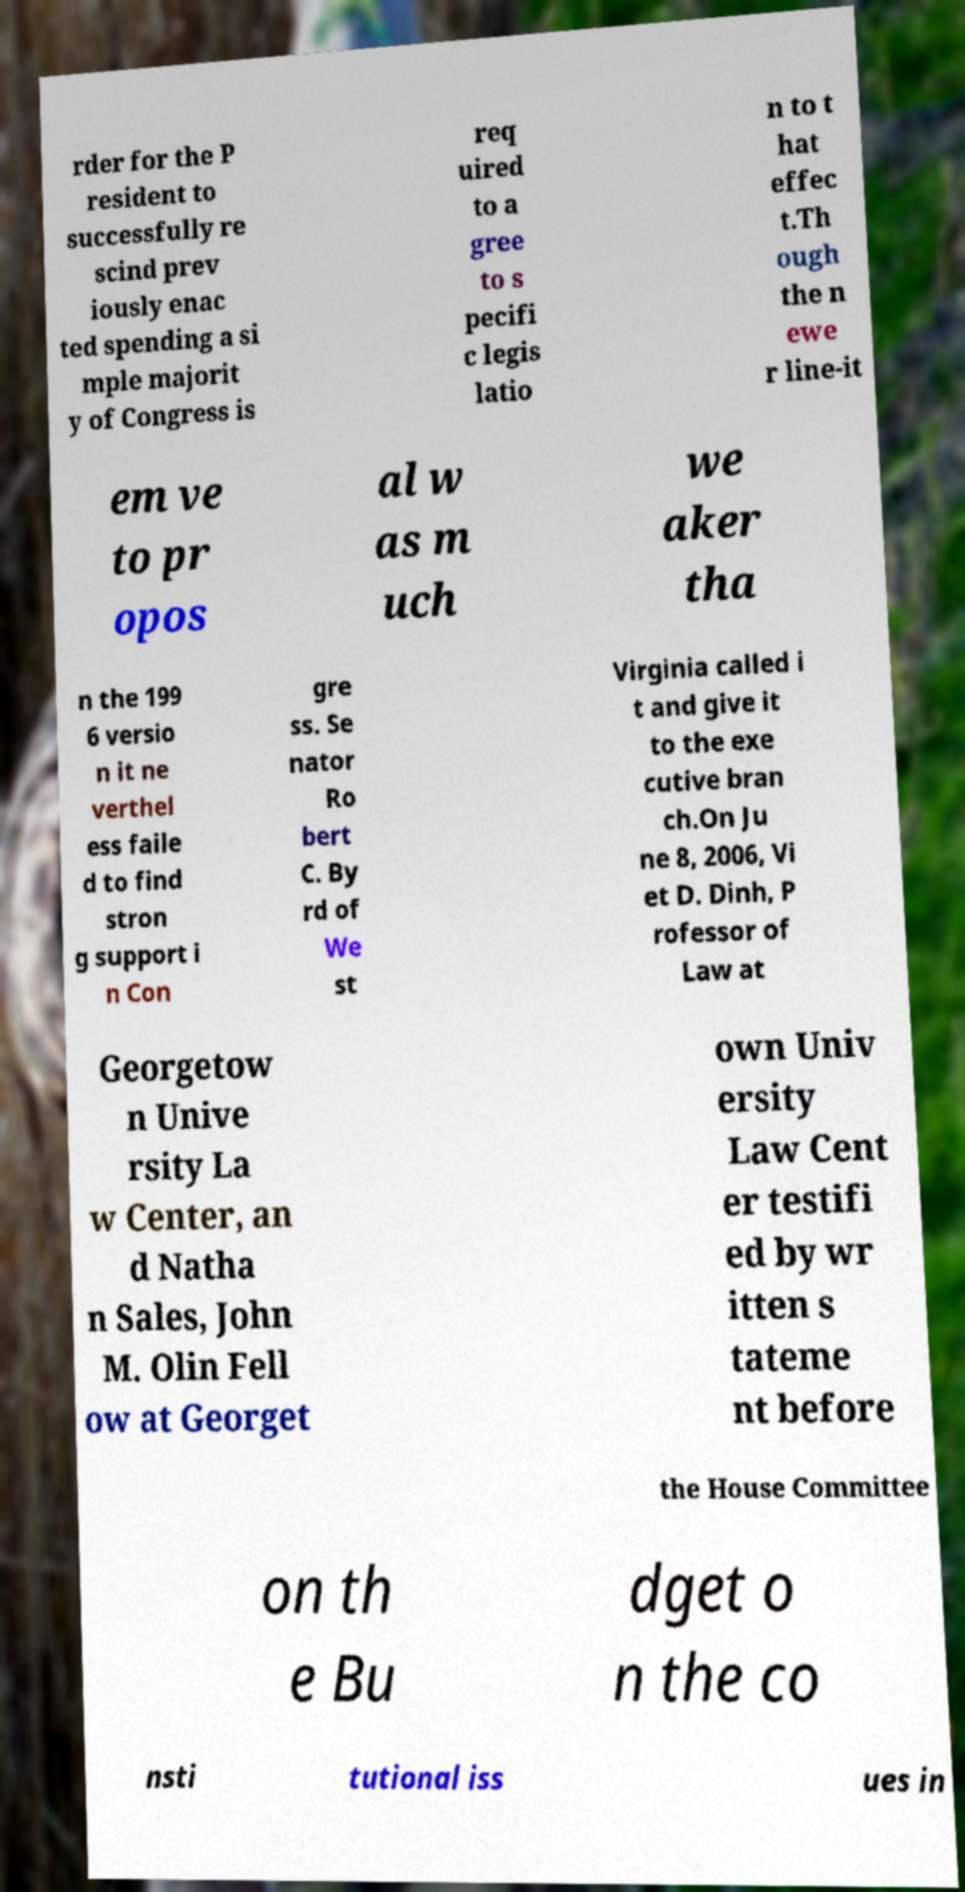Can you accurately transcribe the text from the provided image for me? rder for the P resident to successfully re scind prev iously enac ted spending a si mple majorit y of Congress is req uired to a gree to s pecifi c legis latio n to t hat effec t.Th ough the n ewe r line-it em ve to pr opos al w as m uch we aker tha n the 199 6 versio n it ne verthel ess faile d to find stron g support i n Con gre ss. Se nator Ro bert C. By rd of We st Virginia called i t and give it to the exe cutive bran ch.On Ju ne 8, 2006, Vi et D. Dinh, P rofessor of Law at Georgetow n Unive rsity La w Center, an d Natha n Sales, John M. Olin Fell ow at Georget own Univ ersity Law Cent er testifi ed by wr itten s tateme nt before the House Committee on th e Bu dget o n the co nsti tutional iss ues in 